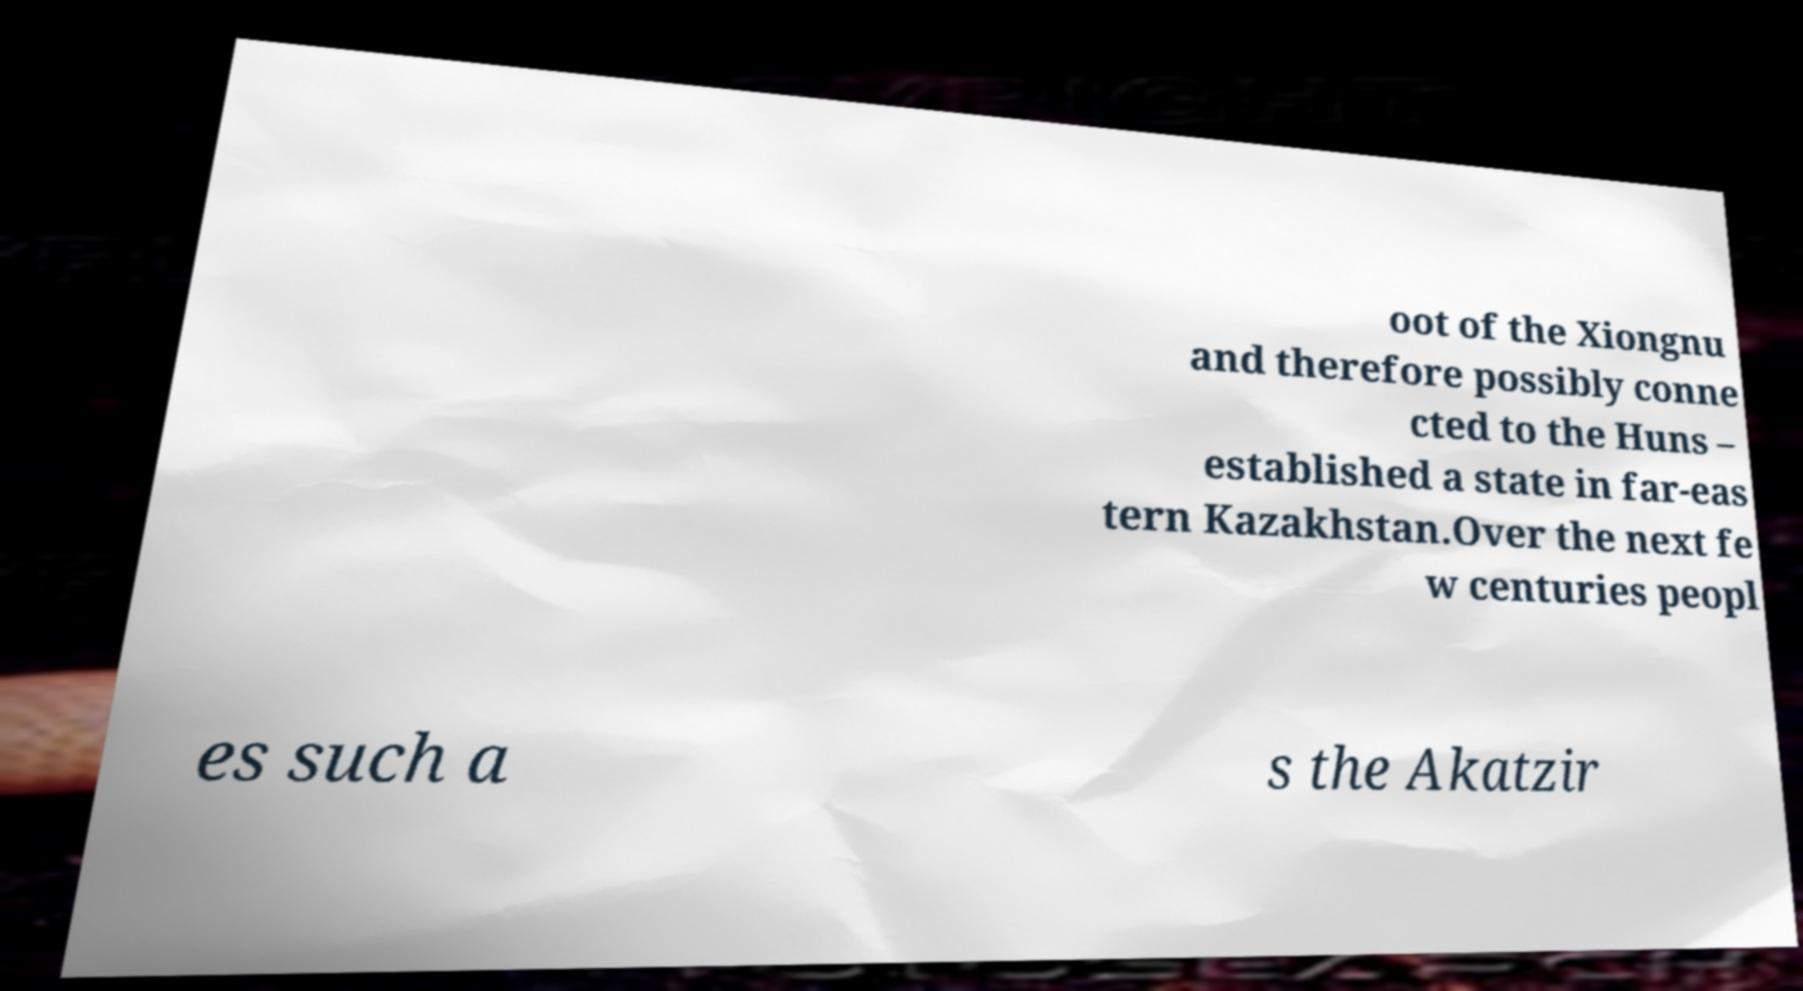Please identify and transcribe the text found in this image. oot of the Xiongnu and therefore possibly conne cted to the Huns – established a state in far-eas tern Kazakhstan.Over the next fe w centuries peopl es such a s the Akatzir 